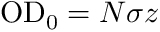Convert formula to latex. <formula><loc_0><loc_0><loc_500><loc_500>{ O D _ { 0 } } = N \sigma z</formula> 